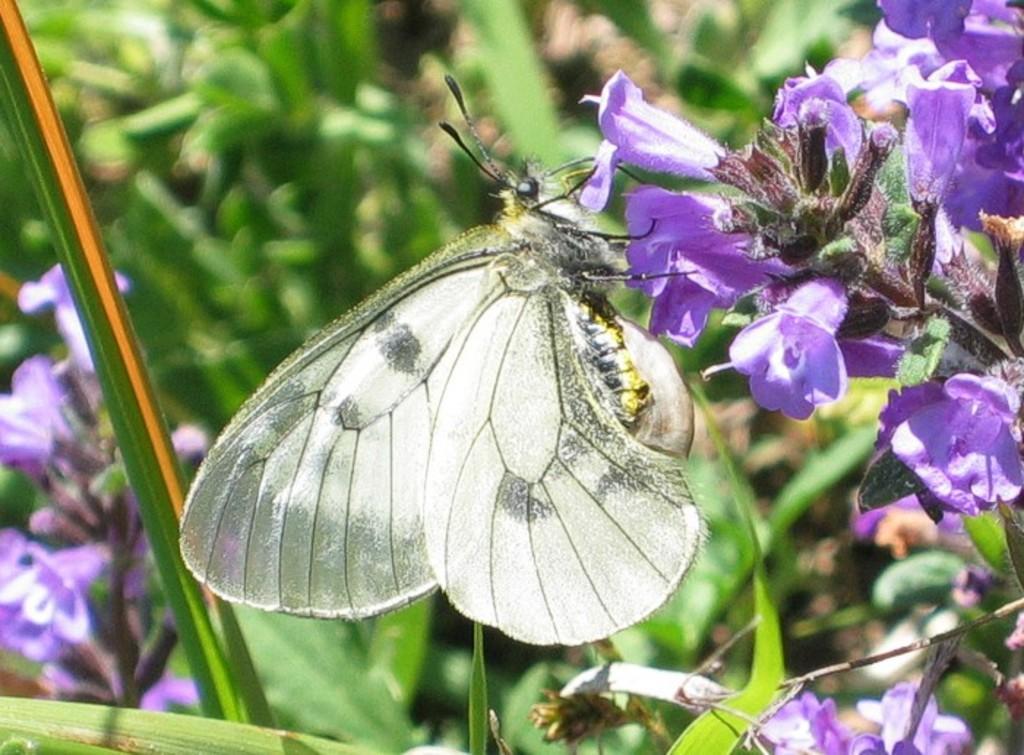Please provide a concise description of this image. In this image, we can see some plants and flowers. We can also see a butterfly. 